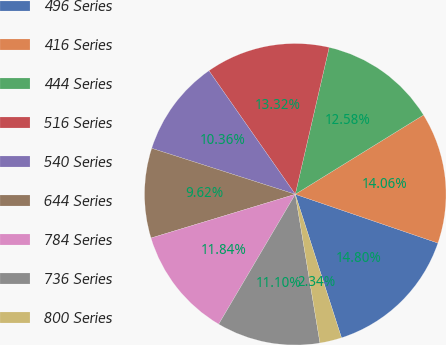Convert chart to OTSL. <chart><loc_0><loc_0><loc_500><loc_500><pie_chart><fcel>496 Series<fcel>416 Series<fcel>444 Series<fcel>516 Series<fcel>540 Series<fcel>644 Series<fcel>784 Series<fcel>736 Series<fcel>800 Series<nl><fcel>14.8%<fcel>14.06%<fcel>12.58%<fcel>13.32%<fcel>10.36%<fcel>9.62%<fcel>11.84%<fcel>11.1%<fcel>2.34%<nl></chart> 